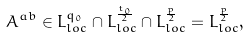<formula> <loc_0><loc_0><loc_500><loc_500>A ^ { a b } \in L ^ { q _ { 0 } } _ { l o c } \cap L ^ { \frac { t _ { 0 } } { 2 } } _ { l o c } \cap L ^ { \frac { p } { 2 } } _ { l o c } = L ^ { \frac { p } { 2 } } _ { l o c } ,</formula> 